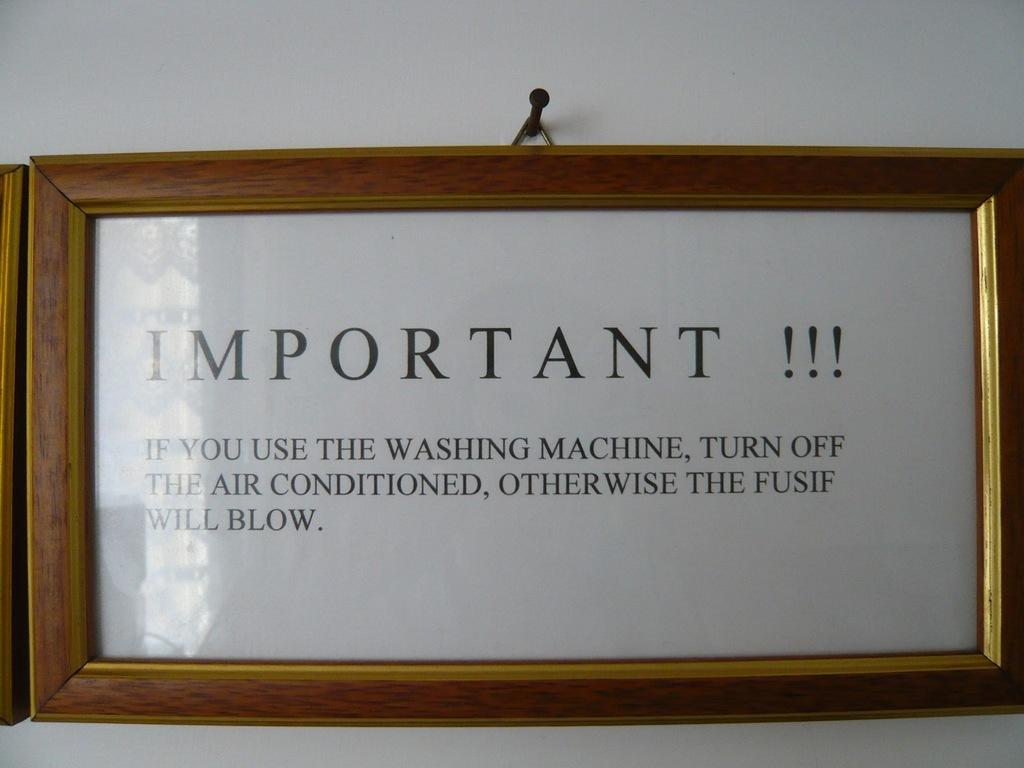<image>
Offer a succinct explanation of the picture presented. A framed sign about turning off the AC while you use the washer so the fuse doesn't blow. 